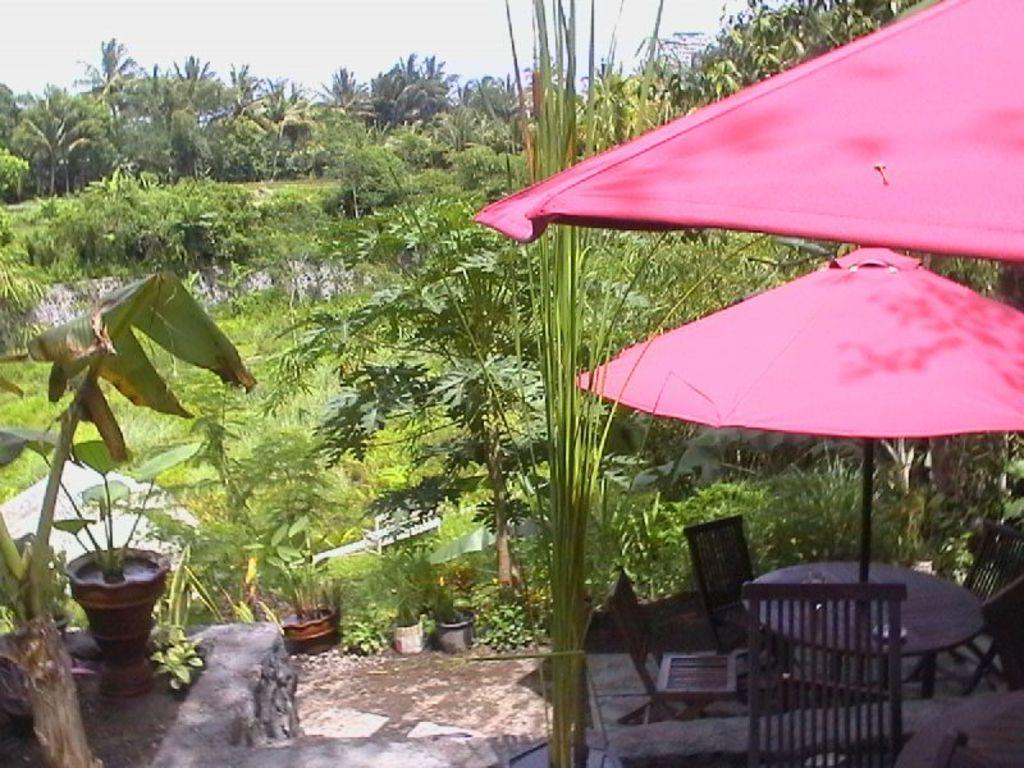What color are the tents in the image? The tents in the image are red. Where are the tents located in relation to the table? The tents are under the table. What type of furniture is present in the image? Chairs are present in the image. What is in the flower pot in the image? There is a plant in the flower pot. Where is the flower pot located in the image? The flower pot is on a wall. What can be seen in the background of the image? Trees and the sky are visible in the background of the image. Can you tell me how many rabbits are hiding under the tents in the image? There are no rabbits present in the image; it only features red color tents, a table, chairs, a flower pot with plants, a wall, trees, and the sky in the background. 